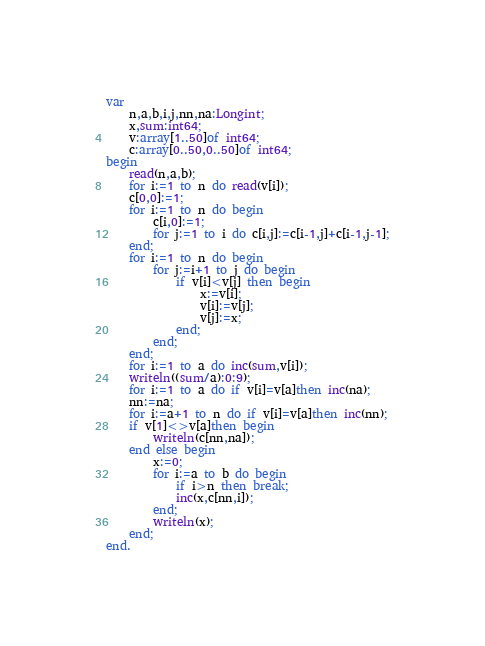Convert code to text. <code><loc_0><loc_0><loc_500><loc_500><_Pascal_>var
	n,a,b,i,j,nn,na:Longint;
	x,sum:int64;
	v:array[1..50]of int64;
	c:array[0..50,0..50]of int64;
begin
	read(n,a,b);
	for i:=1 to n do read(v[i]);
	c[0,0]:=1;
	for i:=1 to n do begin
		c[i,0]:=1;
		for j:=1 to i do c[i,j]:=c[i-1,j]+c[i-1,j-1];
	end;
	for i:=1 to n do begin
		for j:=i+1 to j do begin
			if v[i]<v[j] then begin
				x:=v[i];
				v[i]:=v[j];
				v[j]:=x;
			end;
		end;
	end;
	for i:=1 to a do inc(sum,v[i]);
	writeln((sum/a):0:9);
	for i:=1 to a do if v[i]=v[a]then inc(na);
	nn:=na;
	for i:=a+1 to n do if v[i]=v[a]then inc(nn);
	if v[1]<>v[a]then begin
		writeln(c[nn,na]);
	end else begin
		x:=0;
		for i:=a to b do begin
			if i>n then break;
			inc(x,c[nn,i]);
		end;
		writeln(x);
	end;
end.
</code> 